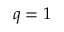<formula> <loc_0><loc_0><loc_500><loc_500>q = 1</formula> 